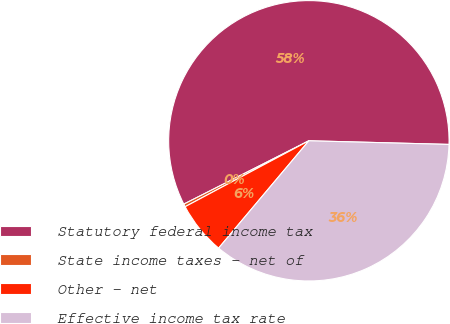<chart> <loc_0><loc_0><loc_500><loc_500><pie_chart><fcel>Statutory federal income tax<fcel>State income taxes - net of<fcel>Other - net<fcel>Effective income tax rate<nl><fcel>57.87%<fcel>0.33%<fcel>6.08%<fcel>35.71%<nl></chart> 